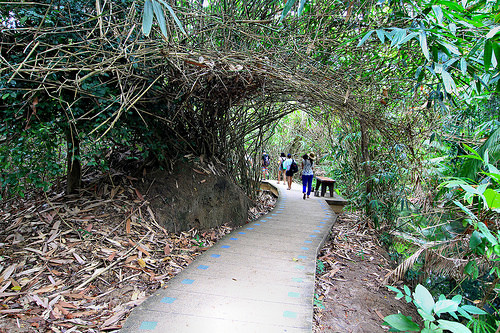<image>
Is there a person on the path? Yes. Looking at the image, I can see the person is positioned on top of the path, with the path providing support. 